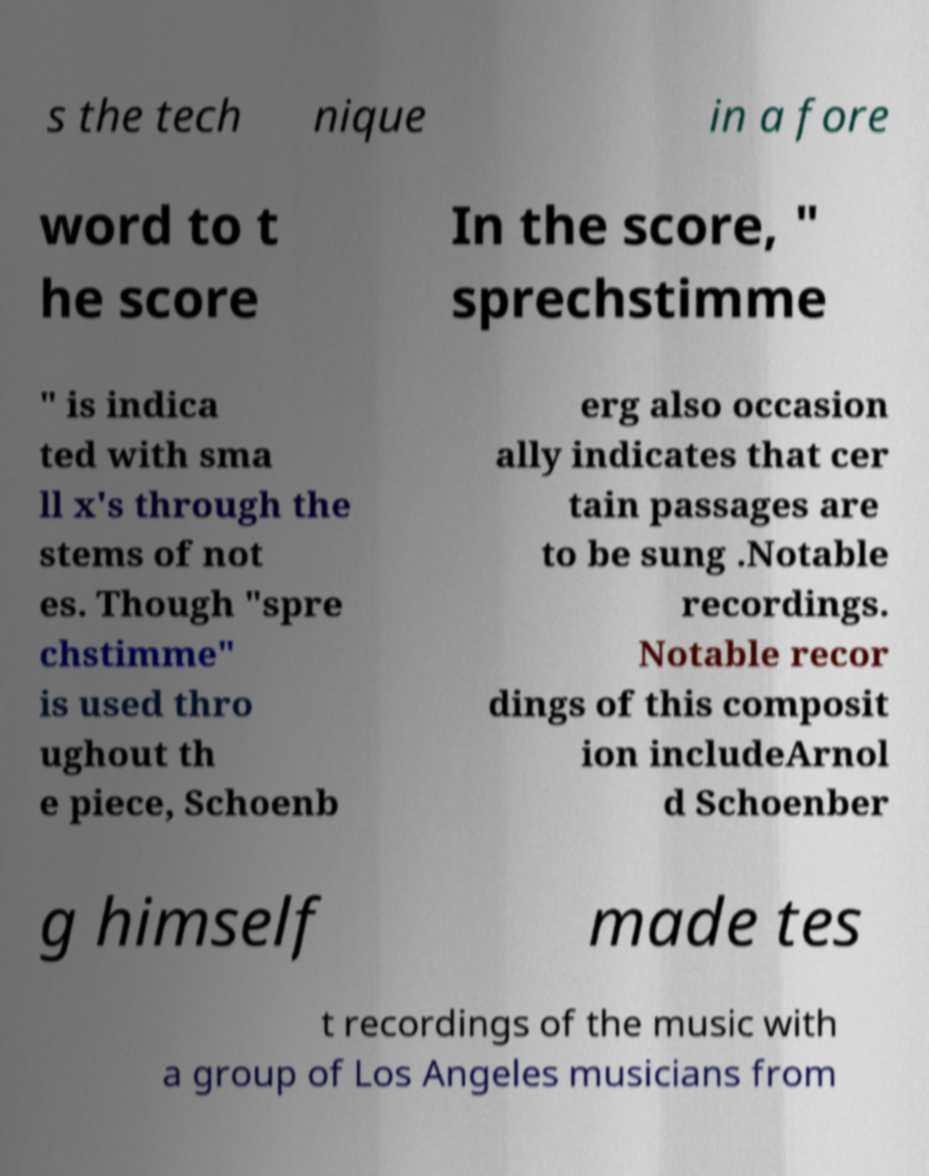Could you assist in decoding the text presented in this image and type it out clearly? s the tech nique in a fore word to t he score In the score, " sprechstimme " is indica ted with sma ll x's through the stems of not es. Though "spre chstimme" is used thro ughout th e piece, Schoenb erg also occasion ally indicates that cer tain passages are to be sung .Notable recordings. Notable recor dings of this composit ion includeArnol d Schoenber g himself made tes t recordings of the music with a group of Los Angeles musicians from 